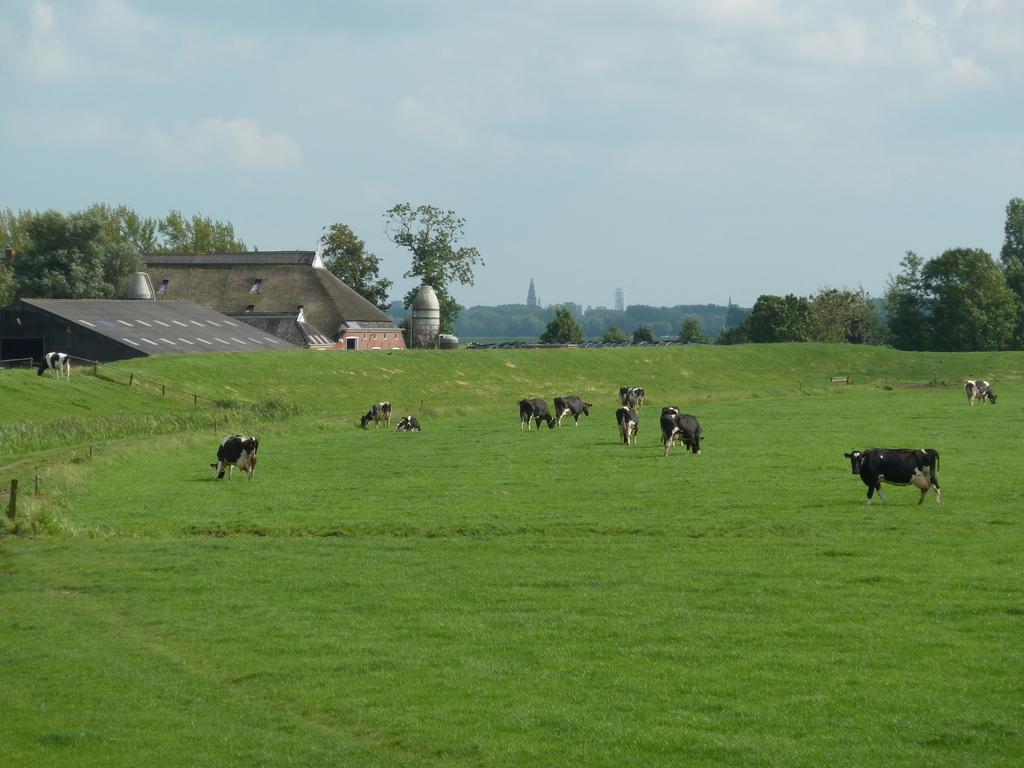Please provide a concise description of this image. This picture is clicked outside. In the center we can see the group of animals standing and seems to be eating the grass. On the left there is an animal seems to be sitting on the ground. In the background we can see the sky, trees, houses, skyscrapers and some other objects. 